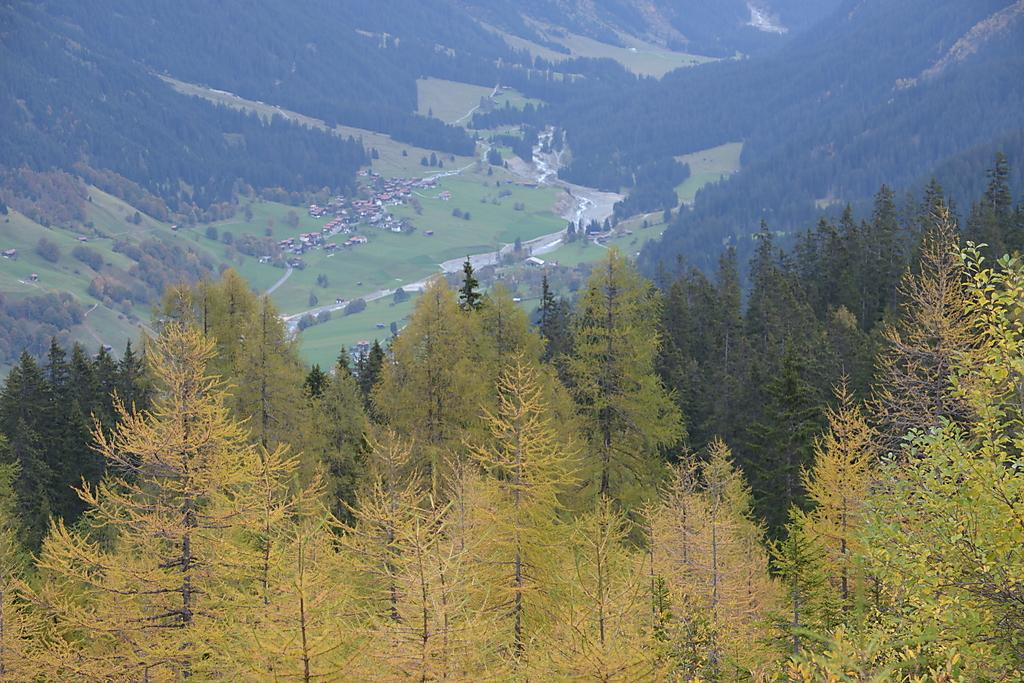What type of vegetation can be seen in the image? There are trees in the image. What type of structures are present in the image? There are houses in the image. What is the pathway for vehicles or people in the image? There is a road in the image. What type of ground cover is visible in the image? There is grass in the image. What type of geographical feature can be seen in the image? There are hills in the image. What is the opinion of the frog about the houses in the image? There is no frog present in the image, so it is not possible to determine its opinion about the houses. 